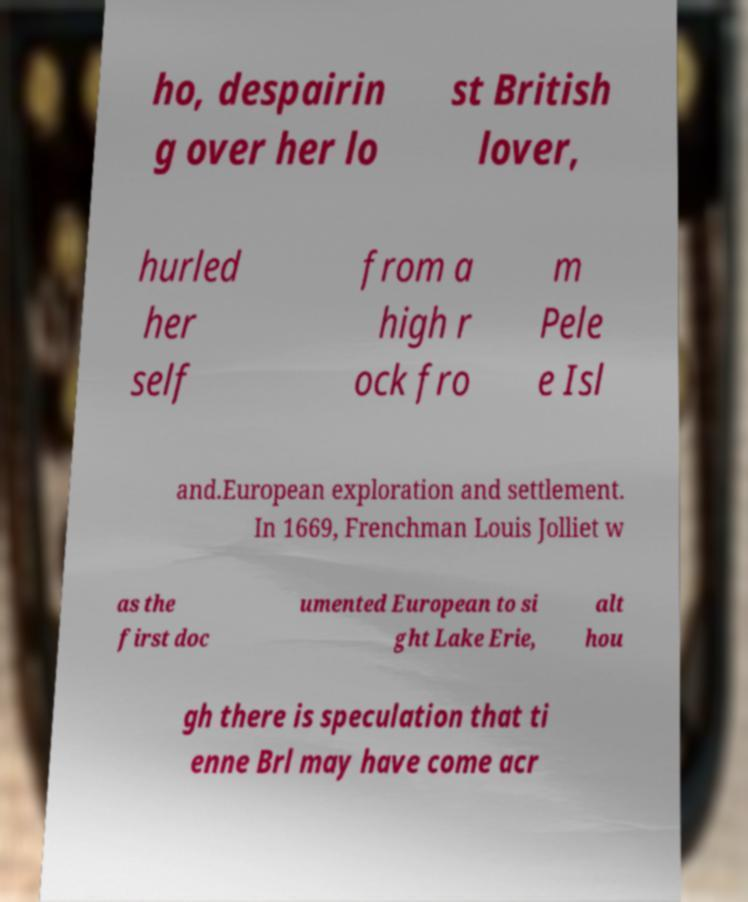I need the written content from this picture converted into text. Can you do that? ho, despairin g over her lo st British lover, hurled her self from a high r ock fro m Pele e Isl and.European exploration and settlement. In 1669, Frenchman Louis Jolliet w as the first doc umented European to si ght Lake Erie, alt hou gh there is speculation that ti enne Brl may have come acr 